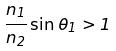<formula> <loc_0><loc_0><loc_500><loc_500>\frac { n _ { 1 } } { n _ { 2 } } \sin \theta _ { 1 } > 1</formula> 